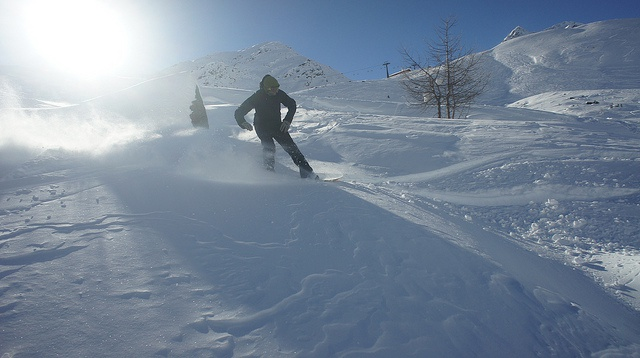Describe the objects in this image and their specific colors. I can see people in white, purple, and black tones and snowboard in white, gray, darkgray, and lightgray tones in this image. 